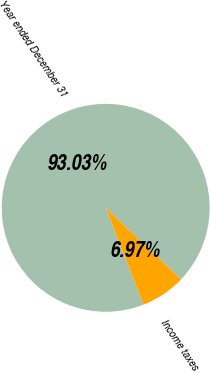Convert chart. <chart><loc_0><loc_0><loc_500><loc_500><pie_chart><fcel>Year ended December 31<fcel>Income taxes<nl><fcel>93.03%<fcel>6.97%<nl></chart> 